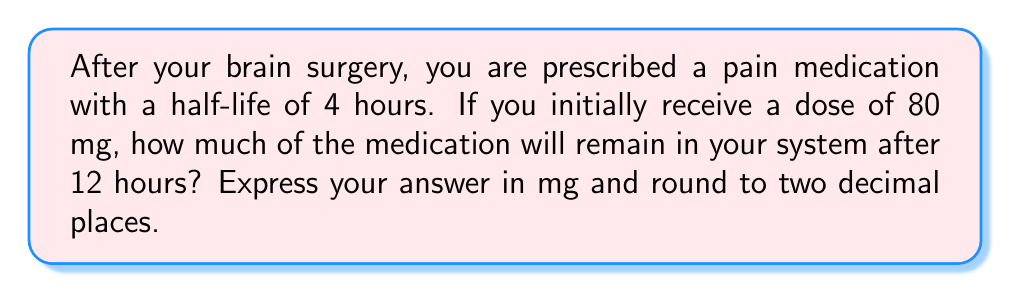Give your solution to this math problem. Let's approach this step-by-step:

1) The half-life of a medication is the time it takes for half of the drug to be eliminated from the body. In this case, the half-life is 4 hours.

2) We need to determine how many half-lives have passed in 12 hours:
   $\text{Number of half-lives} = \frac{\text{Total time}}{\text{Half-life}} = \frac{12 \text{ hours}}{4 \text{ hours}} = 3$

3) After each half-life, the amount of medication is halved. We can represent this mathematically as:

   $\text{Remaining medication} = \text{Initial dose} \times (\frac{1}{2})^n$

   Where $n$ is the number of half-lives that have passed.

4) Plugging in our values:

   $\text{Remaining medication} = 80 \text{ mg} \times (\frac{1}{2})^3$

5) Let's calculate this:

   $80 \times (\frac{1}{2})^3 = 80 \times \frac{1}{8} = 10 \text{ mg}$

Therefore, after 12 hours, 10 mg of the medication will remain in your system.
Answer: 10.00 mg 